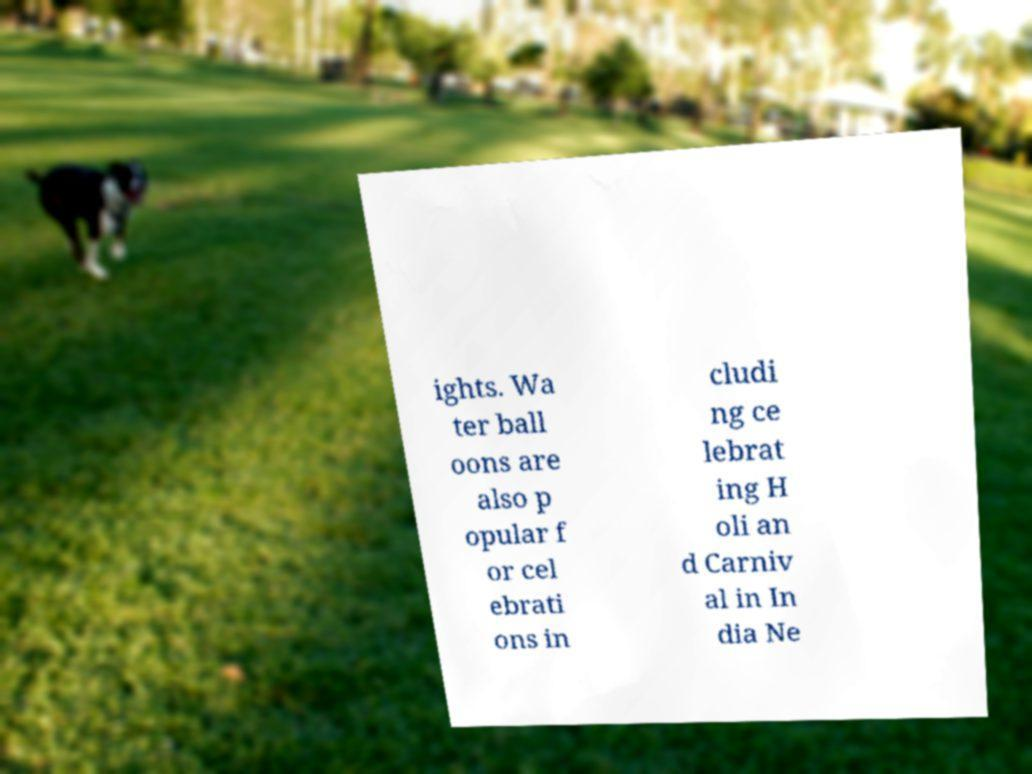Please identify and transcribe the text found in this image. ights. Wa ter ball oons are also p opular f or cel ebrati ons in cludi ng ce lebrat ing H oli an d Carniv al in In dia Ne 